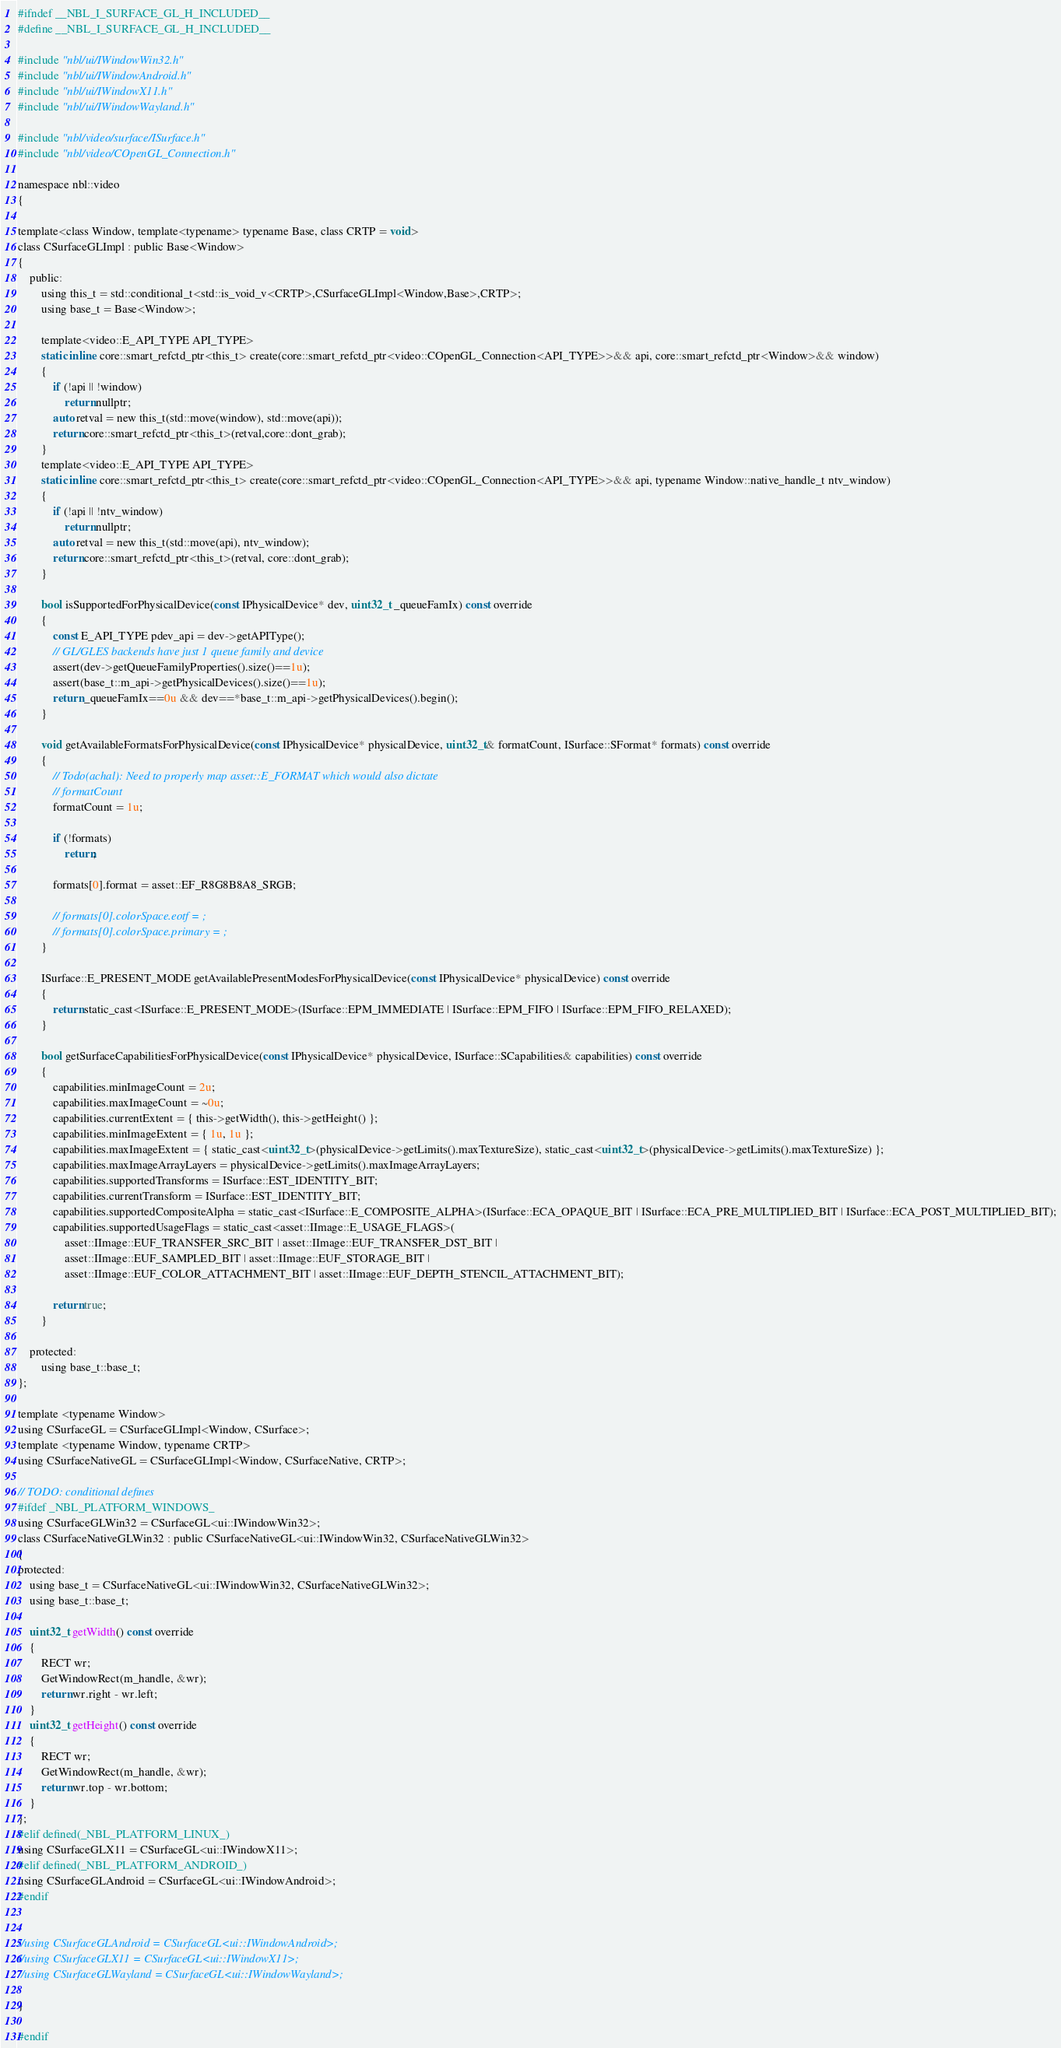Convert code to text. <code><loc_0><loc_0><loc_500><loc_500><_C_>#ifndef __NBL_I_SURFACE_GL_H_INCLUDED__
#define __NBL_I_SURFACE_GL_H_INCLUDED__

#include "nbl/ui/IWindowWin32.h"
#include "nbl/ui/IWindowAndroid.h"
#include "nbl/ui/IWindowX11.h"
#include "nbl/ui/IWindowWayland.h"

#include "nbl/video/surface/ISurface.h"
#include "nbl/video/COpenGL_Connection.h"

namespace nbl::video
{

template<class Window, template<typename> typename Base, class CRTP = void>
class CSurfaceGLImpl : public Base<Window>
{
    public:
        using this_t = std::conditional_t<std::is_void_v<CRTP>,CSurfaceGLImpl<Window,Base>,CRTP>;
        using base_t = Base<Window>;

        template<video::E_API_TYPE API_TYPE>
        static inline core::smart_refctd_ptr<this_t> create(core::smart_refctd_ptr<video::COpenGL_Connection<API_TYPE>>&& api, core::smart_refctd_ptr<Window>&& window)
        {
            if (!api || !window)
                return nullptr;
            auto retval = new this_t(std::move(window), std::move(api));
            return core::smart_refctd_ptr<this_t>(retval,core::dont_grab);
        }
        template<video::E_API_TYPE API_TYPE>
        static inline core::smart_refctd_ptr<this_t> create(core::smart_refctd_ptr<video::COpenGL_Connection<API_TYPE>>&& api, typename Window::native_handle_t ntv_window)
        {
            if (!api || !ntv_window)
                return nullptr;
            auto retval = new this_t(std::move(api), ntv_window);
            return core::smart_refctd_ptr<this_t>(retval, core::dont_grab);
        }

        bool isSupportedForPhysicalDevice(const IPhysicalDevice* dev, uint32_t _queueFamIx) const override
        {
            const E_API_TYPE pdev_api = dev->getAPIType();
            // GL/GLES backends have just 1 queue family and device
            assert(dev->getQueueFamilyProperties().size()==1u);
            assert(base_t::m_api->getPhysicalDevices().size()==1u);
            return _queueFamIx==0u && dev==*base_t::m_api->getPhysicalDevices().begin();
        }
        
        void getAvailableFormatsForPhysicalDevice(const IPhysicalDevice* physicalDevice, uint32_t& formatCount, ISurface::SFormat* formats) const override
        {
            // Todo(achal): Need to properly map asset::E_FORMAT which would also dictate
            // formatCount
            formatCount = 1u;

            if (!formats)
                return;

            formats[0].format = asset::EF_R8G8B8A8_SRGB;

            // formats[0].colorSpace.eotf = ;
            // formats[0].colorSpace.primary = ;
        }

        ISurface::E_PRESENT_MODE getAvailablePresentModesForPhysicalDevice(const IPhysicalDevice* physicalDevice) const override
        {
            return static_cast<ISurface::E_PRESENT_MODE>(ISurface::EPM_IMMEDIATE | ISurface::EPM_FIFO | ISurface::EPM_FIFO_RELAXED);
        }

        bool getSurfaceCapabilitiesForPhysicalDevice(const IPhysicalDevice* physicalDevice, ISurface::SCapabilities& capabilities) const override
        {
            capabilities.minImageCount = 2u;
            capabilities.maxImageCount = ~0u;
            capabilities.currentExtent = { this->getWidth(), this->getHeight() };
            capabilities.minImageExtent = { 1u, 1u };
            capabilities.maxImageExtent = { static_cast<uint32_t>(physicalDevice->getLimits().maxTextureSize), static_cast<uint32_t>(physicalDevice->getLimits().maxTextureSize) };
            capabilities.maxImageArrayLayers = physicalDevice->getLimits().maxImageArrayLayers;
            capabilities.supportedTransforms = ISurface::EST_IDENTITY_BIT;
            capabilities.currentTransform = ISurface::EST_IDENTITY_BIT;
            capabilities.supportedCompositeAlpha = static_cast<ISurface::E_COMPOSITE_ALPHA>(ISurface::ECA_OPAQUE_BIT | ISurface::ECA_PRE_MULTIPLIED_BIT | ISurface::ECA_POST_MULTIPLIED_BIT);
            capabilities.supportedUsageFlags = static_cast<asset::IImage::E_USAGE_FLAGS>(
                asset::IImage::EUF_TRANSFER_SRC_BIT | asset::IImage::EUF_TRANSFER_DST_BIT |
                asset::IImage::EUF_SAMPLED_BIT | asset::IImage::EUF_STORAGE_BIT |
                asset::IImage::EUF_COLOR_ATTACHMENT_BIT | asset::IImage::EUF_DEPTH_STENCIL_ATTACHMENT_BIT);

            return true;
        }

    protected:
        using base_t::base_t;
};

template <typename Window>
using CSurfaceGL = CSurfaceGLImpl<Window, CSurface>;
template <typename Window, typename CRTP>
using CSurfaceNativeGL = CSurfaceGLImpl<Window, CSurfaceNative, CRTP>;

// TODO: conditional defines
#ifdef _NBL_PLATFORM_WINDOWS_
using CSurfaceGLWin32 = CSurfaceGL<ui::IWindowWin32>;
class CSurfaceNativeGLWin32 : public CSurfaceNativeGL<ui::IWindowWin32, CSurfaceNativeGLWin32>
{
protected:
    using base_t = CSurfaceNativeGL<ui::IWindowWin32, CSurfaceNativeGLWin32>;
    using base_t::base_t;

    uint32_t getWidth() const override 
    { 
        RECT wr;
        GetWindowRect(m_handle, &wr);
        return wr.right - wr.left;
    }
    uint32_t getHeight() const override 
    { 
        RECT wr;
        GetWindowRect(m_handle, &wr);
        return wr.top - wr.bottom;
    }
};
#elif defined(_NBL_PLATFORM_LINUX_)
using CSurfaceGLX11 = CSurfaceGL<ui::IWindowX11>;
#elif defined(_NBL_PLATFORM_ANDROID_)
using CSurfaceGLAndroid = CSurfaceGL<ui::IWindowAndroid>;
#endif


//using CSurfaceGLAndroid = CSurfaceGL<ui::IWindowAndroid>;
//using CSurfaceGLX11 = CSurfaceGL<ui::IWindowX11>;
//using CSurfaceGLWayland = CSurfaceGL<ui::IWindowWayland>;

}

#endif</code> 